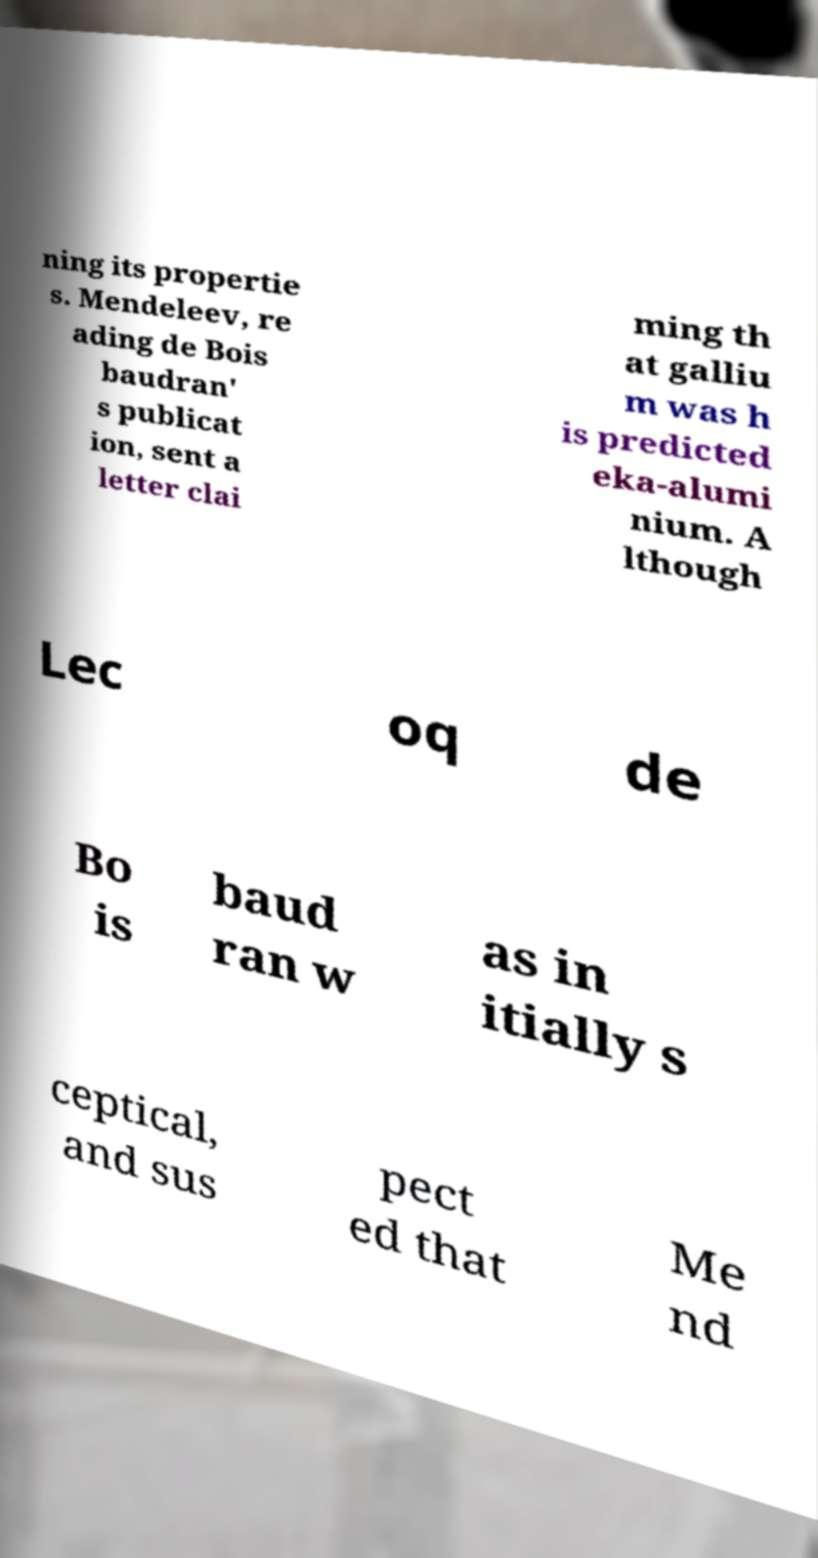I need the written content from this picture converted into text. Can you do that? ning its propertie s. Mendeleev, re ading de Bois baudran' s publicat ion, sent a letter clai ming th at galliu m was h is predicted eka-alumi nium. A lthough Lec oq de Bo is baud ran w as in itially s ceptical, and sus pect ed that Me nd 